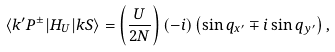<formula> <loc_0><loc_0><loc_500><loc_500>\langle k ^ { \prime } P ^ { \pm } | H _ { U } | k S \rangle = \left ( \frac { U } { 2 N } \right ) ( - i ) \left ( \sin q _ { x ^ { \prime } } \mp i \sin q _ { y ^ { \prime } } \right ) ,</formula> 